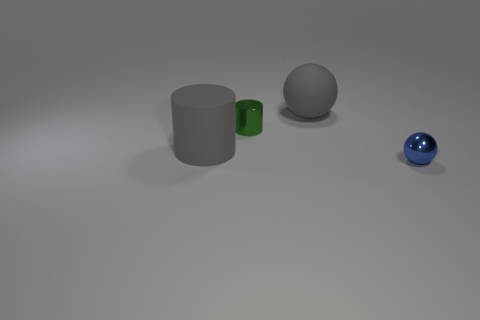Add 2 tiny cyan metallic cubes. How many objects exist? 6 Subtract 0 brown cylinders. How many objects are left? 4 Subtract all big green matte cylinders. Subtract all tiny blue balls. How many objects are left? 3 Add 2 small blue metallic objects. How many small blue metallic objects are left? 3 Add 3 green cylinders. How many green cylinders exist? 4 